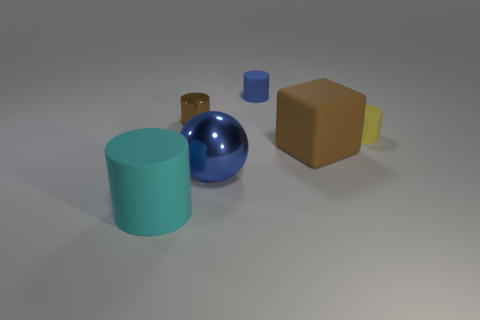What number of metallic cylinders are left of the rubber object that is in front of the brown object that is in front of the yellow rubber thing?
Give a very brief answer. 0. Is the number of large blue balls right of the big cyan rubber thing the same as the number of cyan matte objects?
Your answer should be compact. Yes. What number of cubes are either small yellow objects or small metallic things?
Offer a very short reply. 0. Is the color of the block the same as the big sphere?
Offer a very short reply. No. Is the number of big blue spheres to the left of the brown cylinder the same as the number of blue matte objects on the left side of the cyan rubber object?
Offer a terse response. Yes. What color is the big metallic sphere?
Your answer should be very brief. Blue. How many objects are big rubber things right of the blue metallic thing or cylinders?
Give a very brief answer. 5. There is a brown object to the left of the ball; is it the same size as the thing that is on the left side of the brown cylinder?
Your answer should be very brief. No. Is there any other thing that is made of the same material as the tiny brown thing?
Your answer should be compact. Yes. How many things are either blue objects that are in front of the small blue rubber object or objects that are in front of the yellow rubber cylinder?
Offer a terse response. 3. 